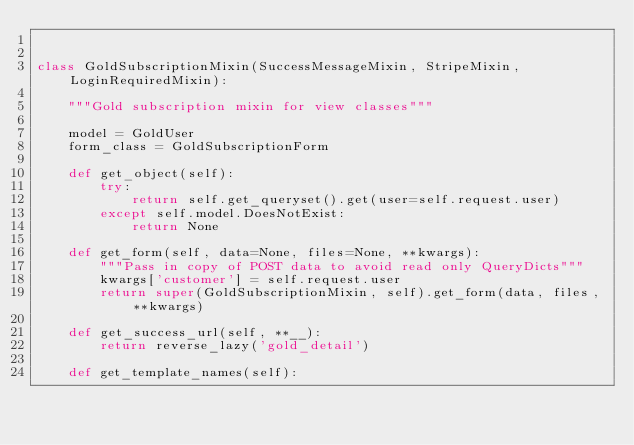Convert code to text. <code><loc_0><loc_0><loc_500><loc_500><_Python_>

class GoldSubscriptionMixin(SuccessMessageMixin, StripeMixin, LoginRequiredMixin):

    """Gold subscription mixin for view classes"""

    model = GoldUser
    form_class = GoldSubscriptionForm

    def get_object(self):
        try:
            return self.get_queryset().get(user=self.request.user)
        except self.model.DoesNotExist:
            return None

    def get_form(self, data=None, files=None, **kwargs):
        """Pass in copy of POST data to avoid read only QueryDicts"""
        kwargs['customer'] = self.request.user
        return super(GoldSubscriptionMixin, self).get_form(data, files, **kwargs)

    def get_success_url(self, **__):
        return reverse_lazy('gold_detail')

    def get_template_names(self):</code> 